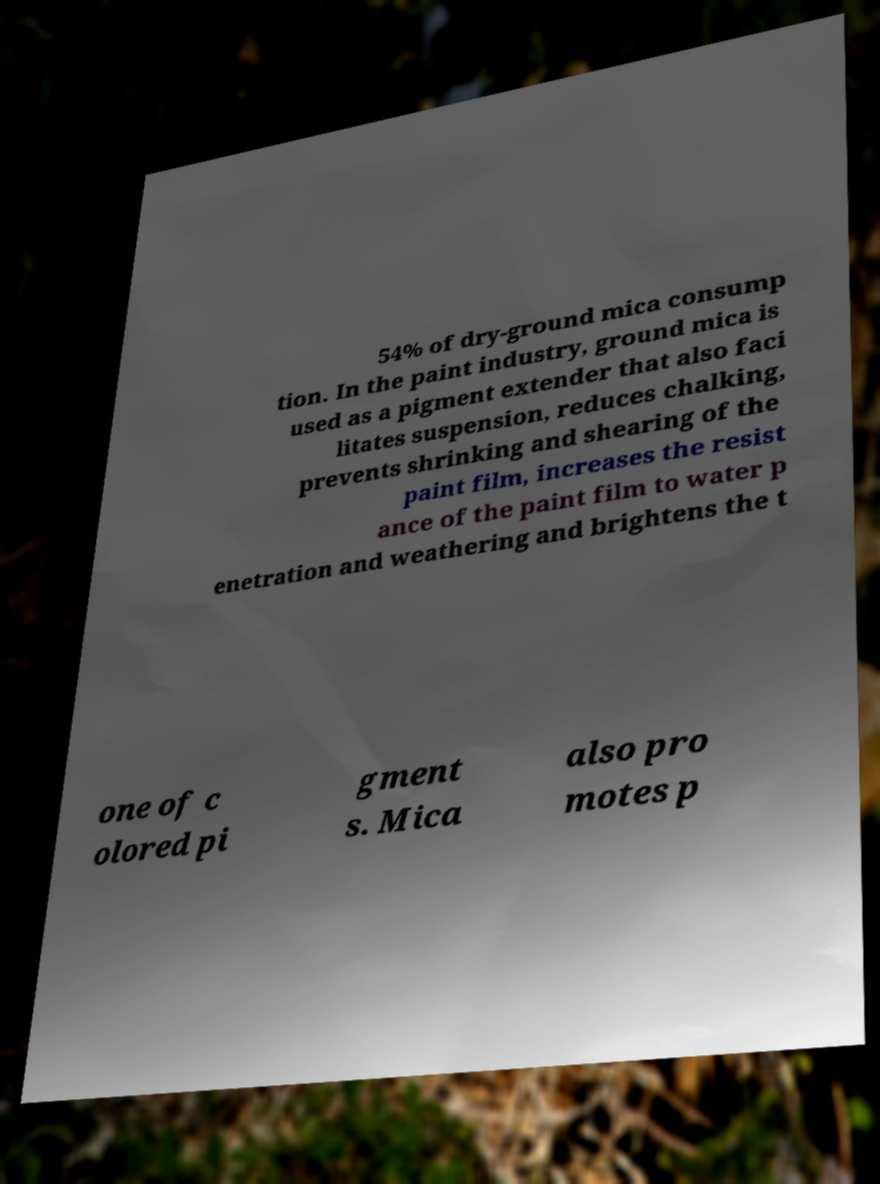What messages or text are displayed in this image? I need them in a readable, typed format. 54% of dry-ground mica consump tion. In the paint industry, ground mica is used as a pigment extender that also faci litates suspension, reduces chalking, prevents shrinking and shearing of the paint film, increases the resist ance of the paint film to water p enetration and weathering and brightens the t one of c olored pi gment s. Mica also pro motes p 